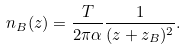Convert formula to latex. <formula><loc_0><loc_0><loc_500><loc_500>n _ { B } ( z ) = \frac { T } { 2 \pi \alpha } \frac { 1 } { ( z + z _ { B } ) ^ { 2 } } .</formula> 